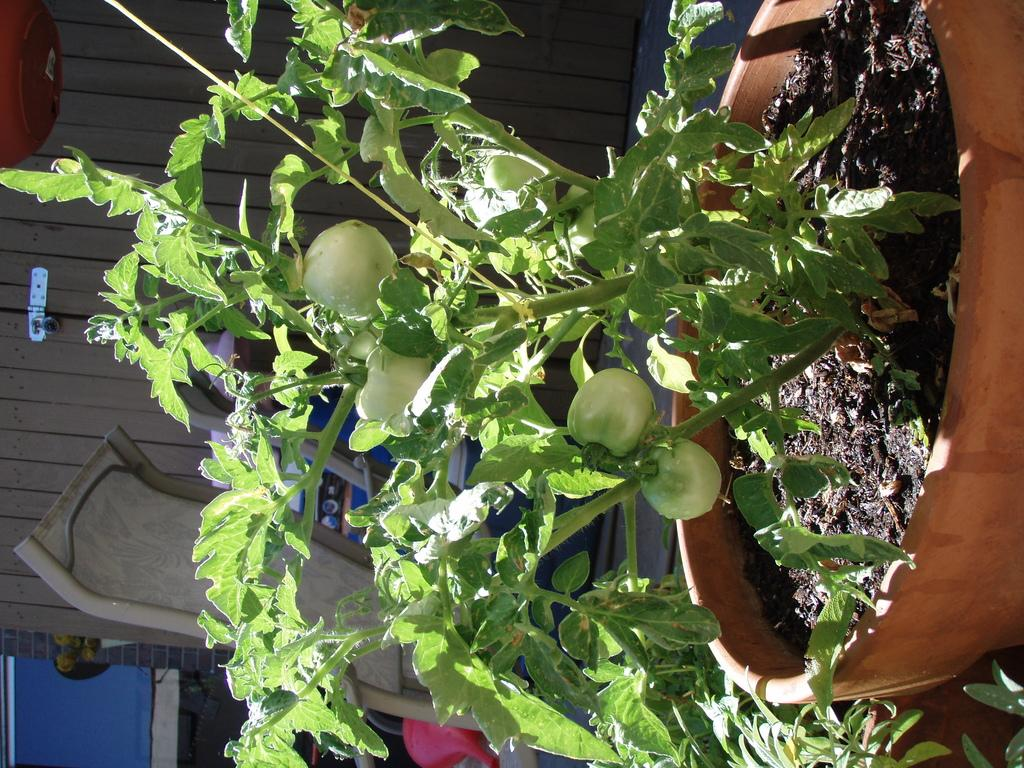What type of plant is in the image? There is a tomato plant in the image. Where is the tomato plant located? The tomato plant is in a pot. What can be seen in the background of the image? There is a building in the background of the image. How many deer are visible in the image? There are no deer present in the image. What number is written on the tomato plant in the image? There is no number written on the tomato plant in the image. 